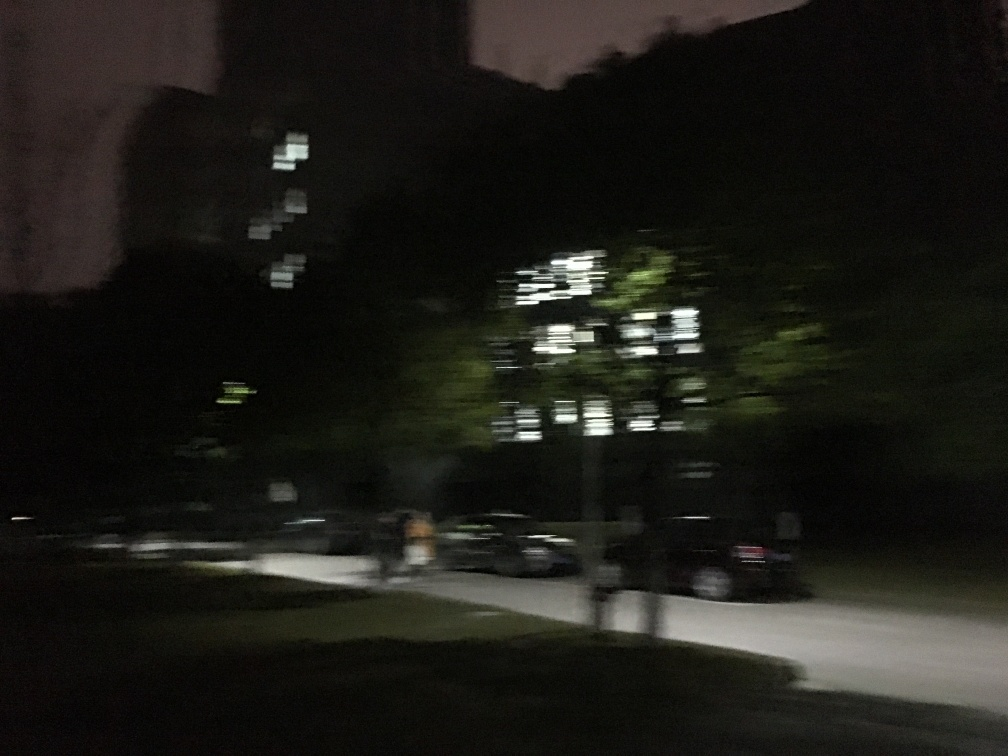Is the image properly exposed?
A. No
B. Yes
Answer with the option's letter from the given choices directly.
 A. 